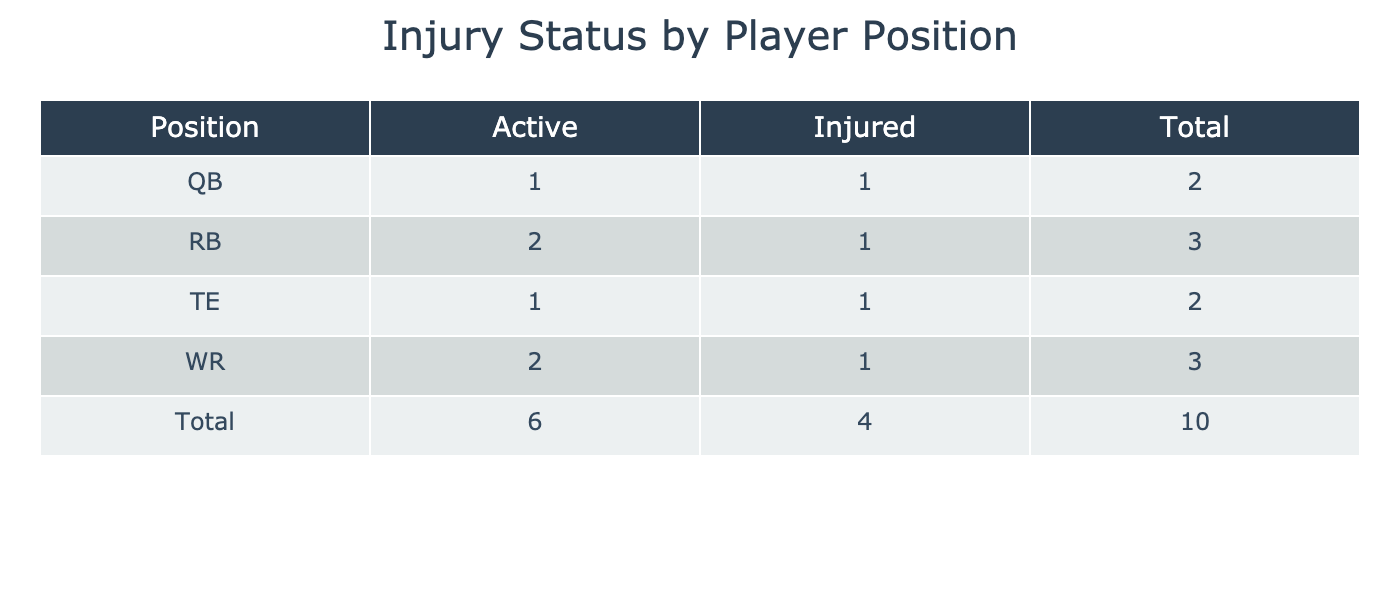What is the total number of Active players by position? To find the total number of Active players by position, we observe the "Active" column in the table. We add the counts of Active players for each position: WR (3) + RB (2) + TE (1) + QB (1) = 7.
Answer: 7 How many players are Injured in the WR position? Looking at the "Injury Status" for the WR position, there is only one player listed as Injured, which is Michael Thomas.
Answer: 1 Is the number of Active RBs greater than the number of Injured WRs? There are 2 Active RBs (Derrick Henry and Dalvin Cook) and 1 Injured WR (Michael Thomas). Since 2 is greater than 1, the statement is true.
Answer: Yes What is the difference in the number of Injured players between the TE and RB positions? The number of Injured TEs is 1 (George Kittle) and the number of Injured RBs is 1 (Saquon Barkley). The difference is 1 - 1 = 0, indicating there is no difference in the number of Injured players between these two positions.
Answer: 0 Which position has the highest number of Active players? By comparing the counts of Active players across different positions, WR has 3, RB has 2, TE has 1, and QB has 1, making WR the position with the highest count of Active players.
Answer: WR How many total players are listed in the table? To find the total number of players listed in the table, we count each individual player entry. There are 10 players in total.
Answer: 10 What percentage of players in the table are Injured? There are 4 Injured players (Michael Thomas, Aaron Rodgers, Saquon Barkley, and George Kittle) out of a total of 10 players. To find the percentage: (4 Injured / 10 Total) * 100% = 40%.
Answer: 40% Are there any TEs that are Active? Checking the injury status for the TE position, there is only one TE (Travis Kelce), and he is listed as Active. Therefore, the answer is yes.
Answer: Yes Which team has an Injured QB player? The table shows that Aaron Rodgers, who plays QB, is Injured and is associated with the Green Bay Packers. Thus, the Green Bay Packers have an Injured QB player.
Answer: Green Bay Packers 